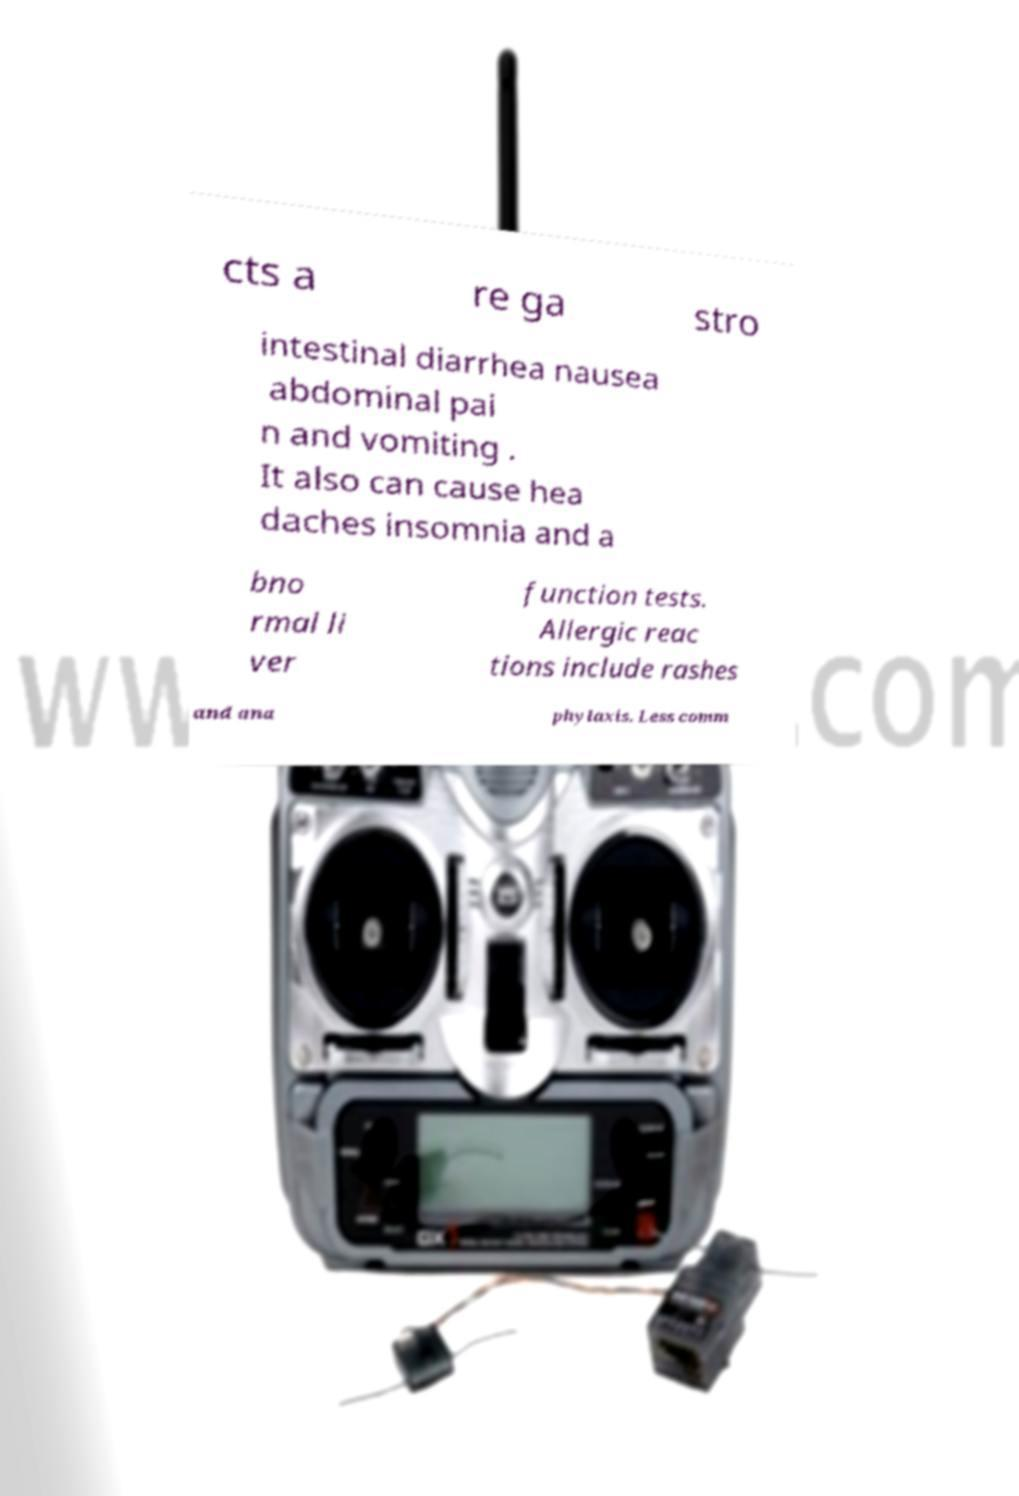There's text embedded in this image that I need extracted. Can you transcribe it verbatim? cts a re ga stro intestinal diarrhea nausea abdominal pai n and vomiting . It also can cause hea daches insomnia and a bno rmal li ver function tests. Allergic reac tions include rashes and ana phylaxis. Less comm 